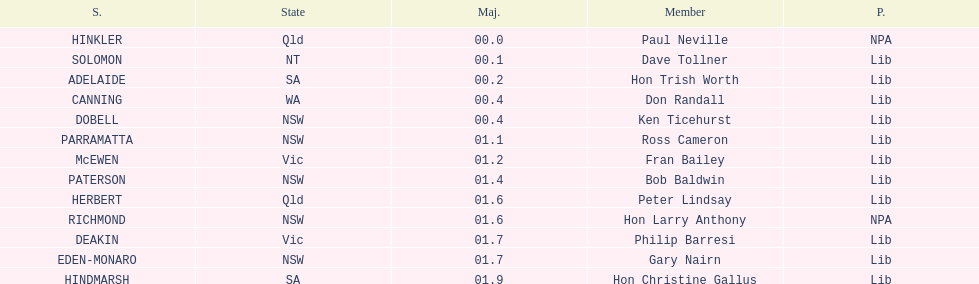Who is the member succeeding hon trish worth? Don Randall. 